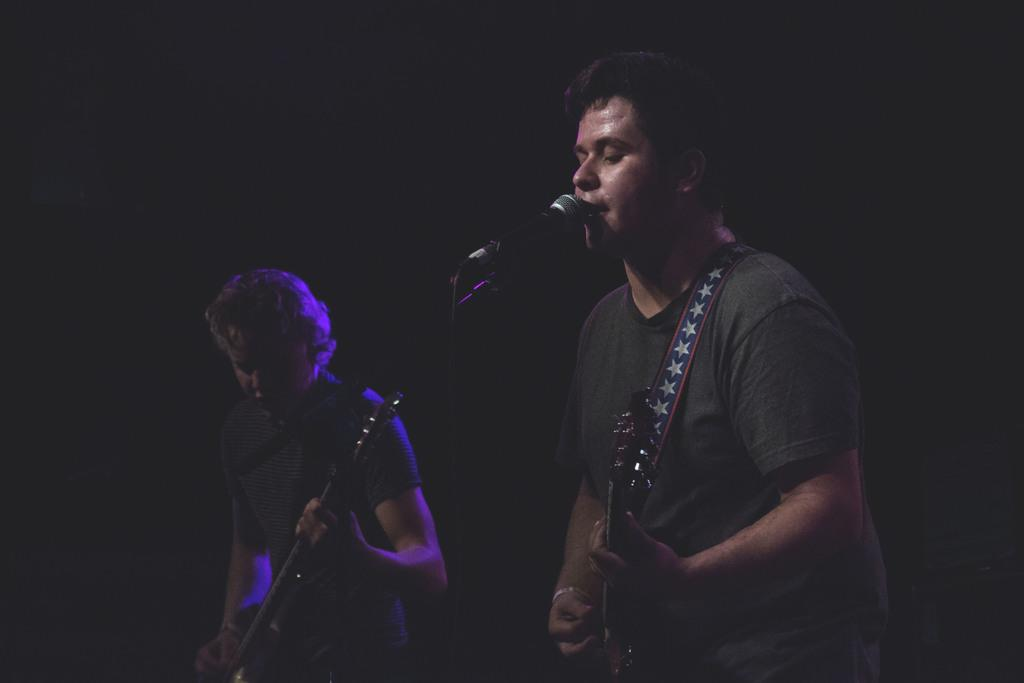What is the lighting condition in the image? The background of the image is dark. What are the two persons in the image doing? They are standing and playing guitar. What is the man in front of the microphone doing? He is singing. What type of sack can be seen in the image? There is no sack present in the image. What advertisement is being promoted in the image? There is no advertisement present in the image. 